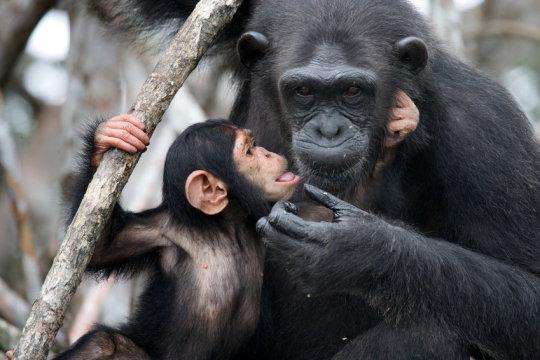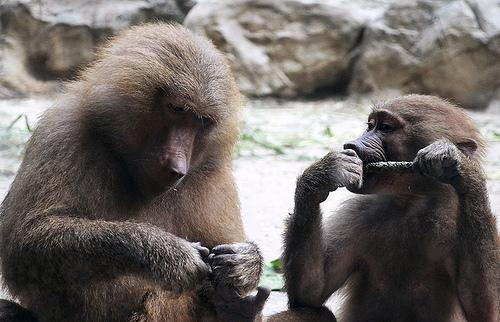The first image is the image on the left, the second image is the image on the right. Considering the images on both sides, is "Six chimps can be seen" valid? Answer yes or no. No. The first image is the image on the left, the second image is the image on the right. Analyze the images presented: Is the assertion "One image includes an adult chimp lying on its side face-to-face with a baby chimp and holding the baby chimp's leg." valid? Answer yes or no. No. 